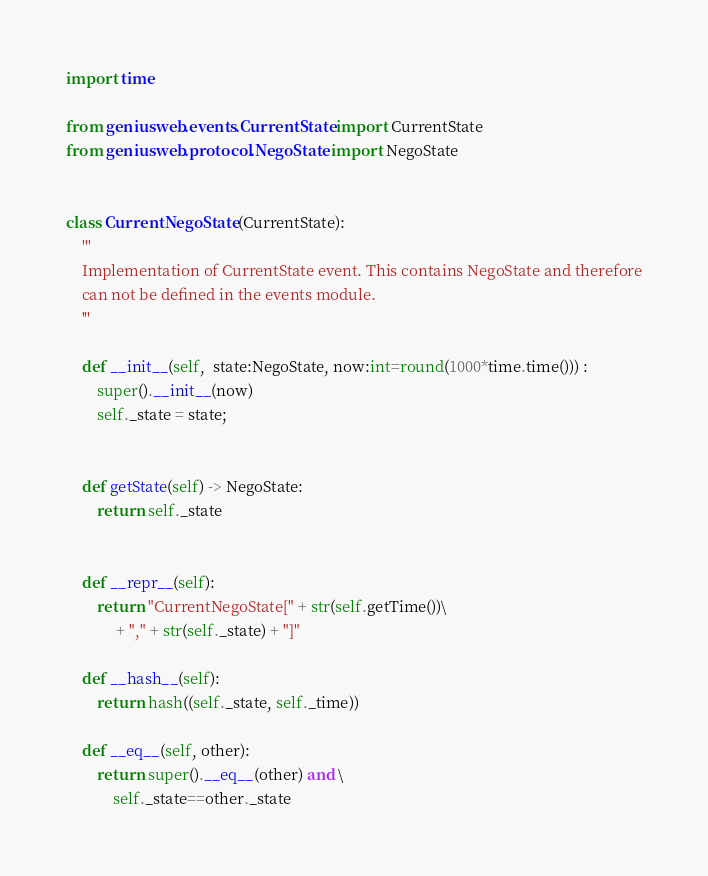<code> <loc_0><loc_0><loc_500><loc_500><_Python_>import time

from geniusweb.events.CurrentState import CurrentState
from geniusweb.protocol.NegoState import NegoState


class CurrentNegoState (CurrentState):
	'''
	Implementation of CurrentState event. This contains NegoState and therefore
	can not be defined in the events module.
	'''

	def __init__(self,  state:NegoState, now:int=round(1000*time.time())) :
		super().__init__(now)
		self._state = state;


	def getState(self) -> NegoState:
		return self._state

		
	def __repr__(self):
		return "CurrentNegoState[" + str(self.getTime())\
			 + "," + str(self._state) + "]"

	def __hash__(self):
		return hash((self._state, self._time))

	def __eq__(self, other):
		return super().__eq__(other) and \
			self._state==other._state
</code> 